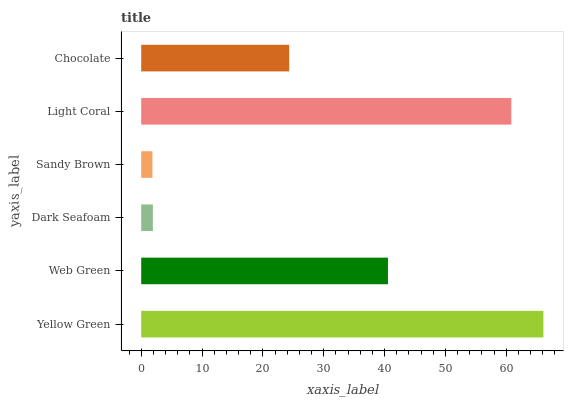Is Sandy Brown the minimum?
Answer yes or no. Yes. Is Yellow Green the maximum?
Answer yes or no. Yes. Is Web Green the minimum?
Answer yes or no. No. Is Web Green the maximum?
Answer yes or no. No. Is Yellow Green greater than Web Green?
Answer yes or no. Yes. Is Web Green less than Yellow Green?
Answer yes or no. Yes. Is Web Green greater than Yellow Green?
Answer yes or no. No. Is Yellow Green less than Web Green?
Answer yes or no. No. Is Web Green the high median?
Answer yes or no. Yes. Is Chocolate the low median?
Answer yes or no. Yes. Is Dark Seafoam the high median?
Answer yes or no. No. Is Web Green the low median?
Answer yes or no. No. 